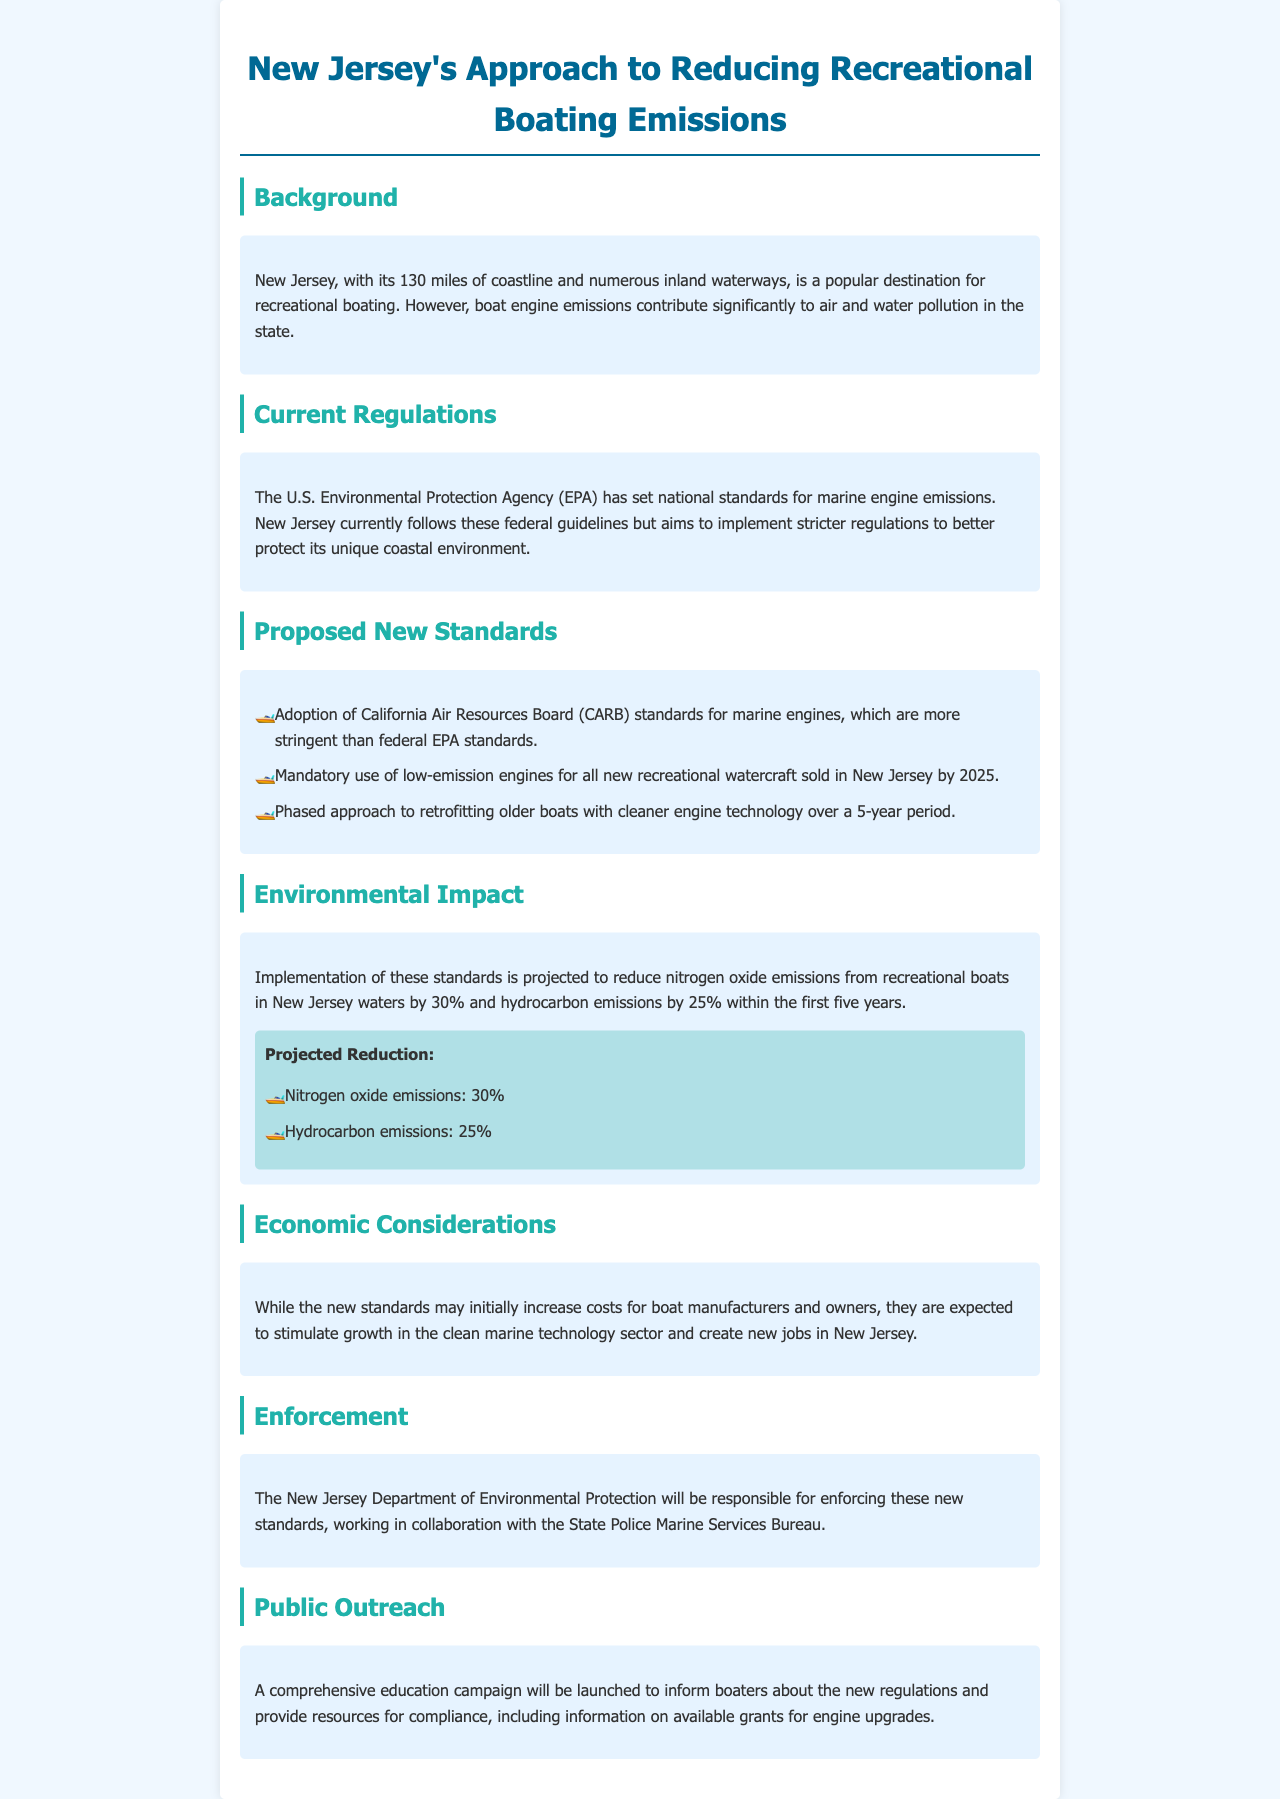What are the projected reductions for nitrogen oxide emissions? The projected reduction for nitrogen oxide emissions is specified in the Environmental Impact section of the document.
Answer: 30% What is the deadline for mandatory use of low-emission engines in New Jersey? The deadline for the mandatory use of low-emission engines is mentioned in the Proposed New Standards section.
Answer: 2025 Who is responsible for enforcing the new standards? The enforcement responsibility is detailed in the Enforcement section of the document.
Answer: New Jersey Department of Environmental Protection What is one of the key benefits expected from the new standards? The key benefit expected is described in the Economic Considerations section, highlighting the impact on the job market.
Answer: Create new jobs What type of pollution is primarily targeted by the new regulations? The main pollution issue targeted is indicated in multiple sections, including Background and Environmental Impact.
Answer: Air and water pollution What authority's standards are New Jersey adopting for marine engines? The authority mentioned in the Proposed New Standards section as the source of the new standards is indicated.
Answer: California Air Resources Board What is the purpose of the public outreach campaign? The purpose of the public outreach campaign is discussed in the Public Outreach section of the document, emphasizing education.
Answer: Inform boaters How long is the phased approach to retrofitting older boats? The duration for the phased approach to retrofitting is clearly stated in the Proposed New Standards section.
Answer: 5 years 